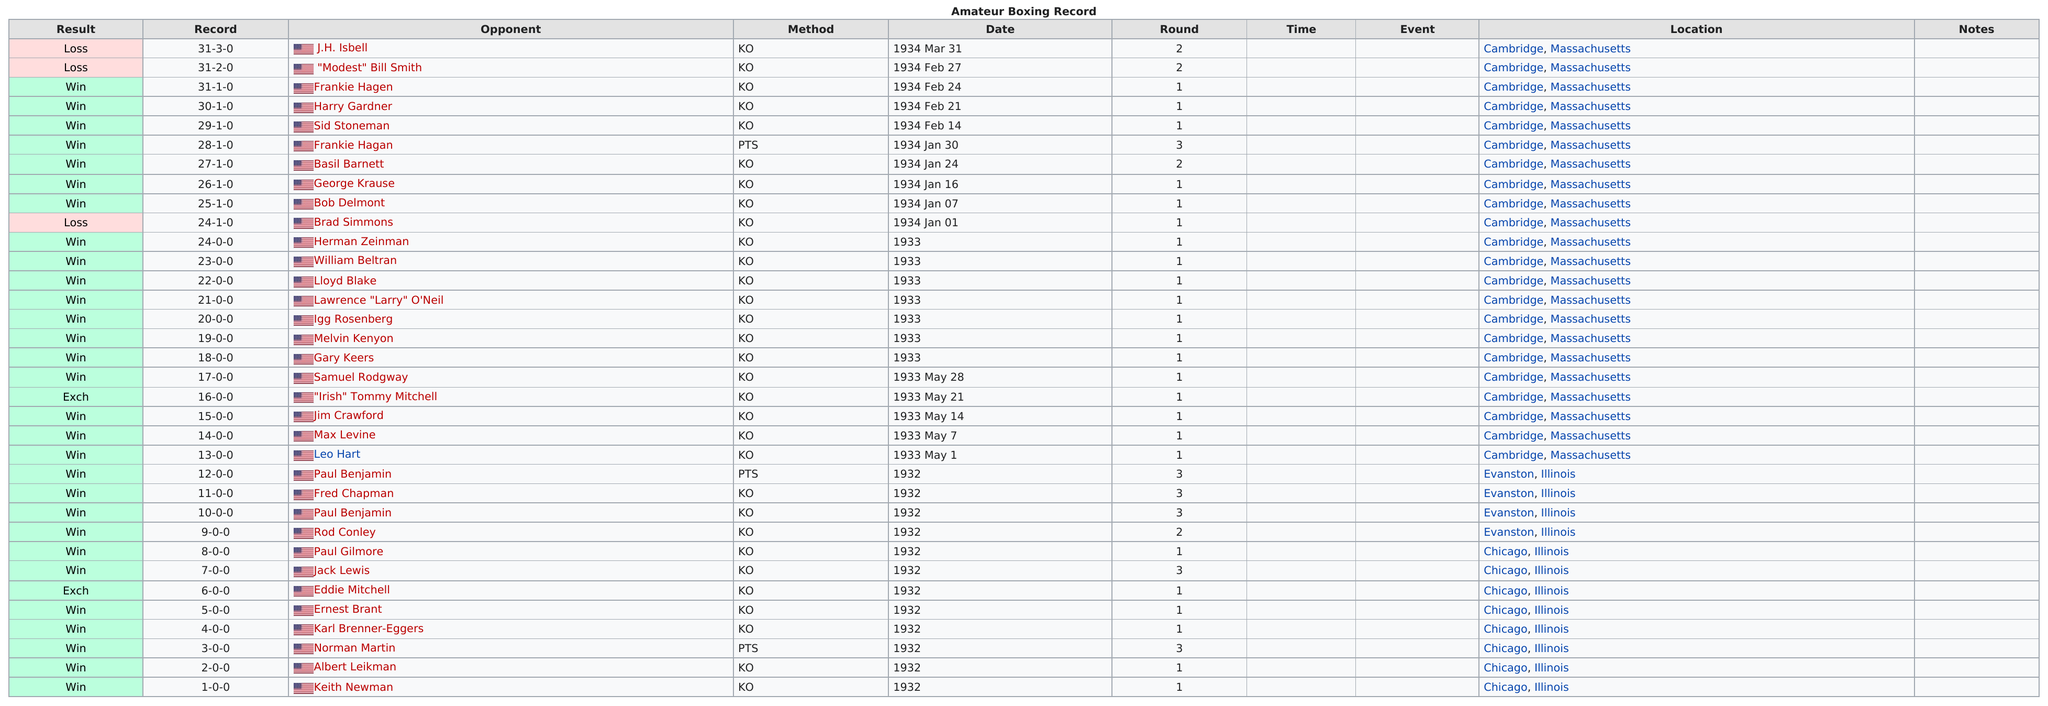List a handful of essential elements in this visual. Tom Neal suffered a total of three losses during his amateur boxing career. 